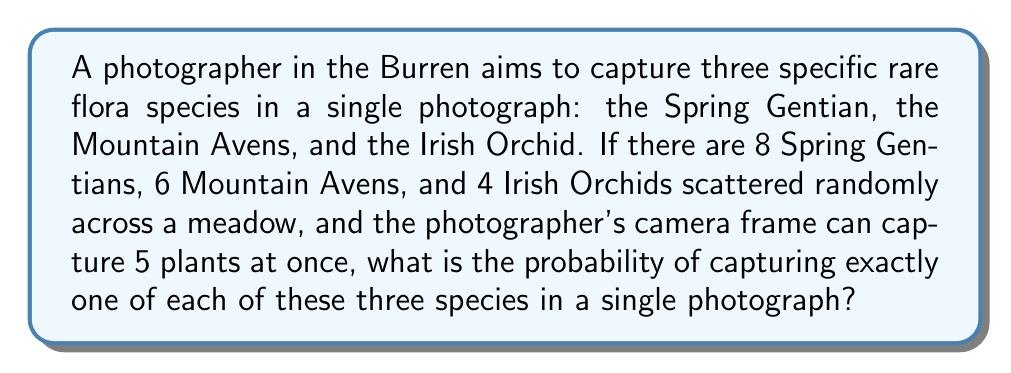Give your solution to this math problem. Let's approach this step-by-step:

1) First, we need to calculate the total number of ways to select 5 plants from the meadow. The total number of plants is 8 + 6 + 4 = 18. We can use the combination formula:

   $$\binom{18}{5} = \frac{18!}{5!(18-5)!} = \frac{18!}{5!13!} = 8568$$

2) Now, we need to calculate the number of favorable outcomes. We want:
   - 1 Spring Gentian (out of 8)
   - 1 Mountain Avens (out of 6)
   - 1 Irish Orchid (out of 4)
   - 2 other plants from the remaining 15 plants

3) We can calculate this using the multiplication principle:

   $$\binom{8}{1} \cdot \binom{6}{1} \cdot \binom{4}{1} \cdot \binom{15}{2}$$

4) Let's calculate each part:
   $$\binom{8}{1} = 8$$
   $$\binom{6}{1} = 6$$
   $$\binom{4}{1} = 4$$
   $$\binom{15}{2} = \frac{15!}{2!13!} = 105$$

5) Multiply these together:

   $$8 \cdot 6 \cdot 4 \cdot 105 = 20160$$

6) The probability is the number of favorable outcomes divided by the total number of possible outcomes:

   $$P = \frac{20160}{8568} = \frac{2520}{1071} \approx 0.2353$$
Answer: $\frac{2520}{1071}$ 